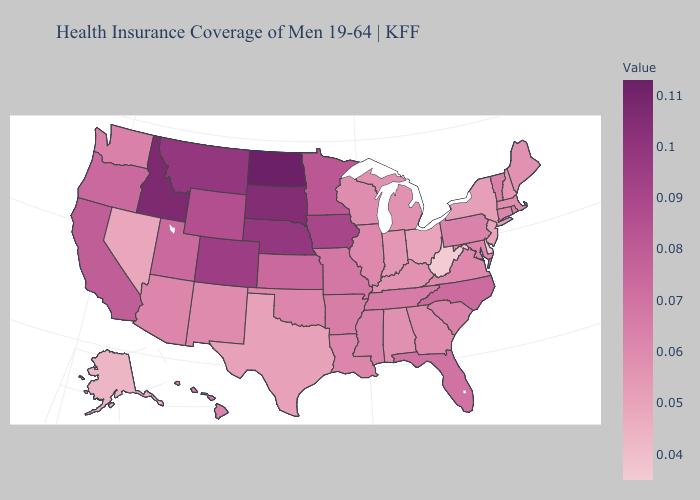Which states have the highest value in the USA?
Keep it brief. North Dakota. Among the states that border Louisiana , does Texas have the lowest value?
Be succinct. Yes. Which states have the highest value in the USA?
Write a very short answer. North Dakota. Does Arizona have a lower value than Nebraska?
Concise answer only. Yes. Among the states that border Idaho , which have the highest value?
Answer briefly. Montana. Does Utah have the highest value in the West?
Write a very short answer. No. 